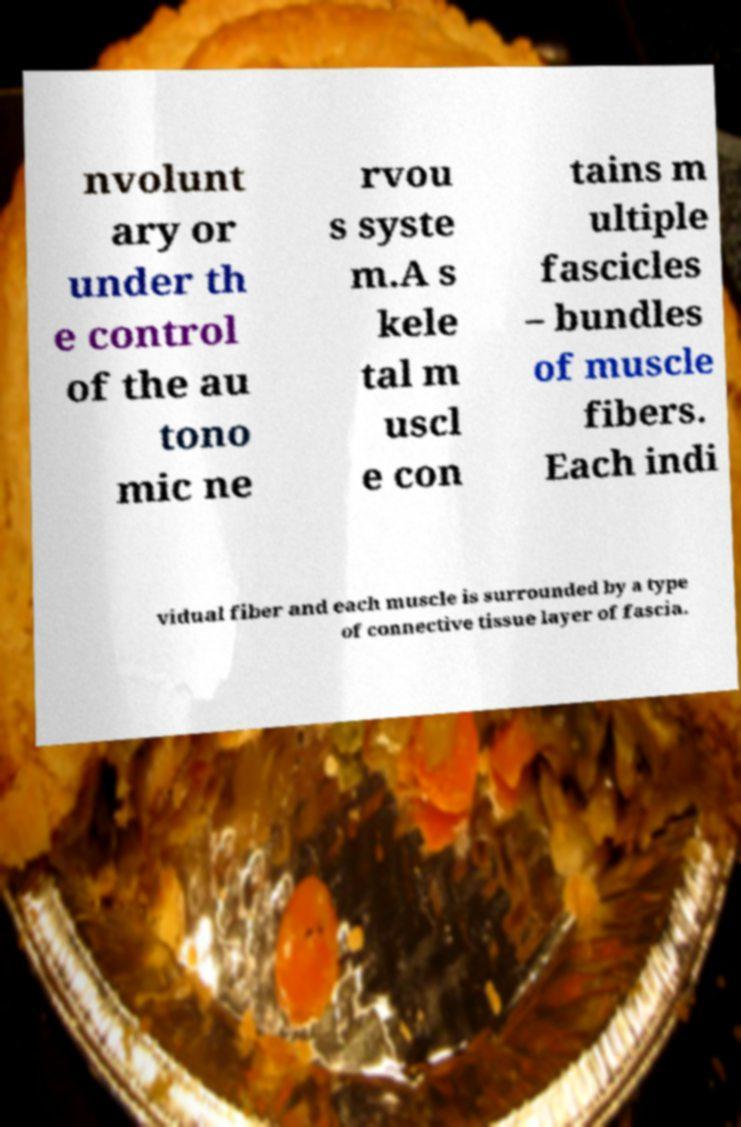Could you assist in decoding the text presented in this image and type it out clearly? nvolunt ary or under th e control of the au tono mic ne rvou s syste m.A s kele tal m uscl e con tains m ultiple fascicles – bundles of muscle fibers. Each indi vidual fiber and each muscle is surrounded by a type of connective tissue layer of fascia. 